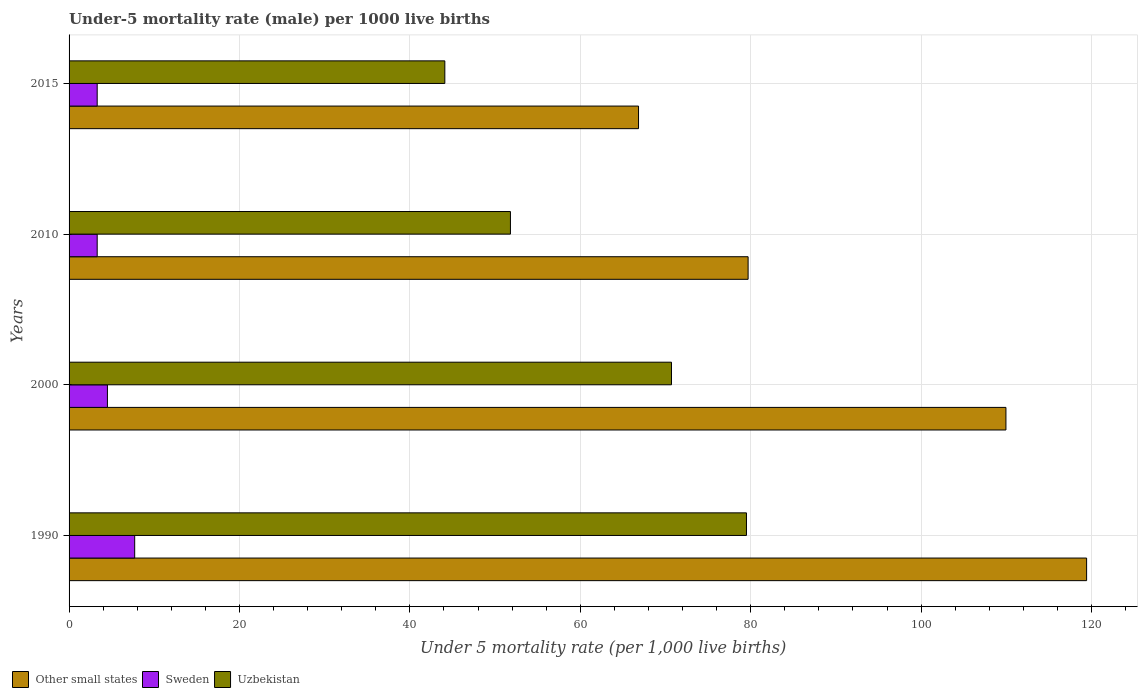How many different coloured bars are there?
Provide a short and direct response. 3. How many groups of bars are there?
Provide a short and direct response. 4. Are the number of bars on each tick of the Y-axis equal?
Your answer should be compact. Yes. What is the label of the 1st group of bars from the top?
Ensure brevity in your answer.  2015. What is the under-five mortality rate in Other small states in 2000?
Your response must be concise. 109.95. Across all years, what is the maximum under-five mortality rate in Uzbekistan?
Provide a succinct answer. 79.5. Across all years, what is the minimum under-five mortality rate in Uzbekistan?
Offer a terse response. 44.1. In which year was the under-five mortality rate in Other small states minimum?
Ensure brevity in your answer.  2015. What is the total under-five mortality rate in Other small states in the graph?
Your answer should be very brief. 375.9. What is the difference between the under-five mortality rate in Other small states in 2000 and that in 2015?
Offer a terse response. 43.12. What is the difference between the under-five mortality rate in Sweden in 1990 and the under-five mortality rate in Other small states in 2010?
Your response must be concise. -71.99. What is the average under-five mortality rate in Other small states per year?
Your response must be concise. 93.97. In the year 2015, what is the difference between the under-five mortality rate in Other small states and under-five mortality rate in Sweden?
Make the answer very short. 63.53. What is the ratio of the under-five mortality rate in Sweden in 1990 to that in 2000?
Offer a terse response. 1.71. What is the difference between the highest and the second highest under-five mortality rate in Uzbekistan?
Provide a short and direct response. 8.8. What is the difference between the highest and the lowest under-five mortality rate in Other small states?
Your answer should be compact. 52.59. In how many years, is the under-five mortality rate in Other small states greater than the average under-five mortality rate in Other small states taken over all years?
Offer a terse response. 2. What does the 3rd bar from the top in 2015 represents?
Ensure brevity in your answer.  Other small states. What does the 1st bar from the bottom in 2015 represents?
Provide a succinct answer. Other small states. Is it the case that in every year, the sum of the under-five mortality rate in Sweden and under-five mortality rate in Uzbekistan is greater than the under-five mortality rate in Other small states?
Provide a short and direct response. No. Are all the bars in the graph horizontal?
Offer a very short reply. Yes. How many years are there in the graph?
Give a very brief answer. 4. How many legend labels are there?
Your answer should be compact. 3. How are the legend labels stacked?
Give a very brief answer. Horizontal. What is the title of the graph?
Keep it short and to the point. Under-5 mortality rate (male) per 1000 live births. Does "Liechtenstein" appear as one of the legend labels in the graph?
Your answer should be compact. No. What is the label or title of the X-axis?
Your response must be concise. Under 5 mortality rate (per 1,0 live births). What is the label or title of the Y-axis?
Your response must be concise. Years. What is the Under 5 mortality rate (per 1,000 live births) of Other small states in 1990?
Ensure brevity in your answer.  119.42. What is the Under 5 mortality rate (per 1,000 live births) in Sweden in 1990?
Keep it short and to the point. 7.7. What is the Under 5 mortality rate (per 1,000 live births) in Uzbekistan in 1990?
Provide a succinct answer. 79.5. What is the Under 5 mortality rate (per 1,000 live births) of Other small states in 2000?
Ensure brevity in your answer.  109.95. What is the Under 5 mortality rate (per 1,000 live births) in Sweden in 2000?
Your answer should be very brief. 4.5. What is the Under 5 mortality rate (per 1,000 live births) in Uzbekistan in 2000?
Offer a terse response. 70.7. What is the Under 5 mortality rate (per 1,000 live births) in Other small states in 2010?
Offer a terse response. 79.69. What is the Under 5 mortality rate (per 1,000 live births) of Uzbekistan in 2010?
Offer a terse response. 51.8. What is the Under 5 mortality rate (per 1,000 live births) in Other small states in 2015?
Give a very brief answer. 66.83. What is the Under 5 mortality rate (per 1,000 live births) of Uzbekistan in 2015?
Ensure brevity in your answer.  44.1. Across all years, what is the maximum Under 5 mortality rate (per 1,000 live births) in Other small states?
Keep it short and to the point. 119.42. Across all years, what is the maximum Under 5 mortality rate (per 1,000 live births) in Uzbekistan?
Offer a very short reply. 79.5. Across all years, what is the minimum Under 5 mortality rate (per 1,000 live births) in Other small states?
Make the answer very short. 66.83. Across all years, what is the minimum Under 5 mortality rate (per 1,000 live births) of Sweden?
Offer a terse response. 3.3. Across all years, what is the minimum Under 5 mortality rate (per 1,000 live births) of Uzbekistan?
Ensure brevity in your answer.  44.1. What is the total Under 5 mortality rate (per 1,000 live births) in Other small states in the graph?
Make the answer very short. 375.9. What is the total Under 5 mortality rate (per 1,000 live births) of Sweden in the graph?
Keep it short and to the point. 18.8. What is the total Under 5 mortality rate (per 1,000 live births) in Uzbekistan in the graph?
Offer a terse response. 246.1. What is the difference between the Under 5 mortality rate (per 1,000 live births) in Other small states in 1990 and that in 2000?
Your response must be concise. 9.47. What is the difference between the Under 5 mortality rate (per 1,000 live births) in Sweden in 1990 and that in 2000?
Your answer should be compact. 3.2. What is the difference between the Under 5 mortality rate (per 1,000 live births) in Other small states in 1990 and that in 2010?
Make the answer very short. 39.73. What is the difference between the Under 5 mortality rate (per 1,000 live births) in Uzbekistan in 1990 and that in 2010?
Provide a short and direct response. 27.7. What is the difference between the Under 5 mortality rate (per 1,000 live births) in Other small states in 1990 and that in 2015?
Give a very brief answer. 52.59. What is the difference between the Under 5 mortality rate (per 1,000 live births) of Sweden in 1990 and that in 2015?
Provide a succinct answer. 4.4. What is the difference between the Under 5 mortality rate (per 1,000 live births) in Uzbekistan in 1990 and that in 2015?
Your answer should be very brief. 35.4. What is the difference between the Under 5 mortality rate (per 1,000 live births) in Other small states in 2000 and that in 2010?
Give a very brief answer. 30.26. What is the difference between the Under 5 mortality rate (per 1,000 live births) of Sweden in 2000 and that in 2010?
Give a very brief answer. 1.2. What is the difference between the Under 5 mortality rate (per 1,000 live births) of Uzbekistan in 2000 and that in 2010?
Your answer should be compact. 18.9. What is the difference between the Under 5 mortality rate (per 1,000 live births) in Other small states in 2000 and that in 2015?
Keep it short and to the point. 43.12. What is the difference between the Under 5 mortality rate (per 1,000 live births) of Uzbekistan in 2000 and that in 2015?
Offer a very short reply. 26.6. What is the difference between the Under 5 mortality rate (per 1,000 live births) in Other small states in 2010 and that in 2015?
Offer a very short reply. 12.86. What is the difference between the Under 5 mortality rate (per 1,000 live births) in Other small states in 1990 and the Under 5 mortality rate (per 1,000 live births) in Sweden in 2000?
Keep it short and to the point. 114.92. What is the difference between the Under 5 mortality rate (per 1,000 live births) of Other small states in 1990 and the Under 5 mortality rate (per 1,000 live births) of Uzbekistan in 2000?
Ensure brevity in your answer.  48.72. What is the difference between the Under 5 mortality rate (per 1,000 live births) of Sweden in 1990 and the Under 5 mortality rate (per 1,000 live births) of Uzbekistan in 2000?
Your answer should be very brief. -63. What is the difference between the Under 5 mortality rate (per 1,000 live births) in Other small states in 1990 and the Under 5 mortality rate (per 1,000 live births) in Sweden in 2010?
Make the answer very short. 116.12. What is the difference between the Under 5 mortality rate (per 1,000 live births) of Other small states in 1990 and the Under 5 mortality rate (per 1,000 live births) of Uzbekistan in 2010?
Make the answer very short. 67.62. What is the difference between the Under 5 mortality rate (per 1,000 live births) in Sweden in 1990 and the Under 5 mortality rate (per 1,000 live births) in Uzbekistan in 2010?
Your answer should be compact. -44.1. What is the difference between the Under 5 mortality rate (per 1,000 live births) of Other small states in 1990 and the Under 5 mortality rate (per 1,000 live births) of Sweden in 2015?
Provide a succinct answer. 116.12. What is the difference between the Under 5 mortality rate (per 1,000 live births) of Other small states in 1990 and the Under 5 mortality rate (per 1,000 live births) of Uzbekistan in 2015?
Ensure brevity in your answer.  75.32. What is the difference between the Under 5 mortality rate (per 1,000 live births) in Sweden in 1990 and the Under 5 mortality rate (per 1,000 live births) in Uzbekistan in 2015?
Offer a terse response. -36.4. What is the difference between the Under 5 mortality rate (per 1,000 live births) of Other small states in 2000 and the Under 5 mortality rate (per 1,000 live births) of Sweden in 2010?
Provide a short and direct response. 106.65. What is the difference between the Under 5 mortality rate (per 1,000 live births) of Other small states in 2000 and the Under 5 mortality rate (per 1,000 live births) of Uzbekistan in 2010?
Make the answer very short. 58.15. What is the difference between the Under 5 mortality rate (per 1,000 live births) of Sweden in 2000 and the Under 5 mortality rate (per 1,000 live births) of Uzbekistan in 2010?
Give a very brief answer. -47.3. What is the difference between the Under 5 mortality rate (per 1,000 live births) of Other small states in 2000 and the Under 5 mortality rate (per 1,000 live births) of Sweden in 2015?
Your answer should be very brief. 106.65. What is the difference between the Under 5 mortality rate (per 1,000 live births) in Other small states in 2000 and the Under 5 mortality rate (per 1,000 live births) in Uzbekistan in 2015?
Provide a succinct answer. 65.85. What is the difference between the Under 5 mortality rate (per 1,000 live births) in Sweden in 2000 and the Under 5 mortality rate (per 1,000 live births) in Uzbekistan in 2015?
Your answer should be very brief. -39.6. What is the difference between the Under 5 mortality rate (per 1,000 live births) in Other small states in 2010 and the Under 5 mortality rate (per 1,000 live births) in Sweden in 2015?
Provide a succinct answer. 76.39. What is the difference between the Under 5 mortality rate (per 1,000 live births) in Other small states in 2010 and the Under 5 mortality rate (per 1,000 live births) in Uzbekistan in 2015?
Make the answer very short. 35.59. What is the difference between the Under 5 mortality rate (per 1,000 live births) of Sweden in 2010 and the Under 5 mortality rate (per 1,000 live births) of Uzbekistan in 2015?
Your answer should be very brief. -40.8. What is the average Under 5 mortality rate (per 1,000 live births) of Other small states per year?
Your answer should be compact. 93.97. What is the average Under 5 mortality rate (per 1,000 live births) in Uzbekistan per year?
Provide a succinct answer. 61.52. In the year 1990, what is the difference between the Under 5 mortality rate (per 1,000 live births) of Other small states and Under 5 mortality rate (per 1,000 live births) of Sweden?
Provide a succinct answer. 111.72. In the year 1990, what is the difference between the Under 5 mortality rate (per 1,000 live births) in Other small states and Under 5 mortality rate (per 1,000 live births) in Uzbekistan?
Make the answer very short. 39.92. In the year 1990, what is the difference between the Under 5 mortality rate (per 1,000 live births) of Sweden and Under 5 mortality rate (per 1,000 live births) of Uzbekistan?
Your answer should be very brief. -71.8. In the year 2000, what is the difference between the Under 5 mortality rate (per 1,000 live births) of Other small states and Under 5 mortality rate (per 1,000 live births) of Sweden?
Your answer should be compact. 105.45. In the year 2000, what is the difference between the Under 5 mortality rate (per 1,000 live births) of Other small states and Under 5 mortality rate (per 1,000 live births) of Uzbekistan?
Ensure brevity in your answer.  39.25. In the year 2000, what is the difference between the Under 5 mortality rate (per 1,000 live births) in Sweden and Under 5 mortality rate (per 1,000 live births) in Uzbekistan?
Your answer should be very brief. -66.2. In the year 2010, what is the difference between the Under 5 mortality rate (per 1,000 live births) of Other small states and Under 5 mortality rate (per 1,000 live births) of Sweden?
Ensure brevity in your answer.  76.39. In the year 2010, what is the difference between the Under 5 mortality rate (per 1,000 live births) of Other small states and Under 5 mortality rate (per 1,000 live births) of Uzbekistan?
Your answer should be compact. 27.89. In the year 2010, what is the difference between the Under 5 mortality rate (per 1,000 live births) in Sweden and Under 5 mortality rate (per 1,000 live births) in Uzbekistan?
Ensure brevity in your answer.  -48.5. In the year 2015, what is the difference between the Under 5 mortality rate (per 1,000 live births) in Other small states and Under 5 mortality rate (per 1,000 live births) in Sweden?
Ensure brevity in your answer.  63.53. In the year 2015, what is the difference between the Under 5 mortality rate (per 1,000 live births) of Other small states and Under 5 mortality rate (per 1,000 live births) of Uzbekistan?
Offer a very short reply. 22.73. In the year 2015, what is the difference between the Under 5 mortality rate (per 1,000 live births) in Sweden and Under 5 mortality rate (per 1,000 live births) in Uzbekistan?
Make the answer very short. -40.8. What is the ratio of the Under 5 mortality rate (per 1,000 live births) of Other small states in 1990 to that in 2000?
Your answer should be very brief. 1.09. What is the ratio of the Under 5 mortality rate (per 1,000 live births) in Sweden in 1990 to that in 2000?
Offer a terse response. 1.71. What is the ratio of the Under 5 mortality rate (per 1,000 live births) in Uzbekistan in 1990 to that in 2000?
Your answer should be very brief. 1.12. What is the ratio of the Under 5 mortality rate (per 1,000 live births) of Other small states in 1990 to that in 2010?
Offer a terse response. 1.5. What is the ratio of the Under 5 mortality rate (per 1,000 live births) of Sweden in 1990 to that in 2010?
Your answer should be compact. 2.33. What is the ratio of the Under 5 mortality rate (per 1,000 live births) in Uzbekistan in 1990 to that in 2010?
Provide a short and direct response. 1.53. What is the ratio of the Under 5 mortality rate (per 1,000 live births) in Other small states in 1990 to that in 2015?
Provide a succinct answer. 1.79. What is the ratio of the Under 5 mortality rate (per 1,000 live births) of Sweden in 1990 to that in 2015?
Your answer should be compact. 2.33. What is the ratio of the Under 5 mortality rate (per 1,000 live births) of Uzbekistan in 1990 to that in 2015?
Give a very brief answer. 1.8. What is the ratio of the Under 5 mortality rate (per 1,000 live births) in Other small states in 2000 to that in 2010?
Keep it short and to the point. 1.38. What is the ratio of the Under 5 mortality rate (per 1,000 live births) in Sweden in 2000 to that in 2010?
Keep it short and to the point. 1.36. What is the ratio of the Under 5 mortality rate (per 1,000 live births) in Uzbekistan in 2000 to that in 2010?
Provide a short and direct response. 1.36. What is the ratio of the Under 5 mortality rate (per 1,000 live births) of Other small states in 2000 to that in 2015?
Provide a short and direct response. 1.65. What is the ratio of the Under 5 mortality rate (per 1,000 live births) of Sweden in 2000 to that in 2015?
Provide a succinct answer. 1.36. What is the ratio of the Under 5 mortality rate (per 1,000 live births) of Uzbekistan in 2000 to that in 2015?
Your answer should be very brief. 1.6. What is the ratio of the Under 5 mortality rate (per 1,000 live births) in Other small states in 2010 to that in 2015?
Give a very brief answer. 1.19. What is the ratio of the Under 5 mortality rate (per 1,000 live births) in Uzbekistan in 2010 to that in 2015?
Your answer should be compact. 1.17. What is the difference between the highest and the second highest Under 5 mortality rate (per 1,000 live births) of Other small states?
Offer a very short reply. 9.47. What is the difference between the highest and the second highest Under 5 mortality rate (per 1,000 live births) in Uzbekistan?
Provide a succinct answer. 8.8. What is the difference between the highest and the lowest Under 5 mortality rate (per 1,000 live births) of Other small states?
Keep it short and to the point. 52.59. What is the difference between the highest and the lowest Under 5 mortality rate (per 1,000 live births) in Uzbekistan?
Ensure brevity in your answer.  35.4. 